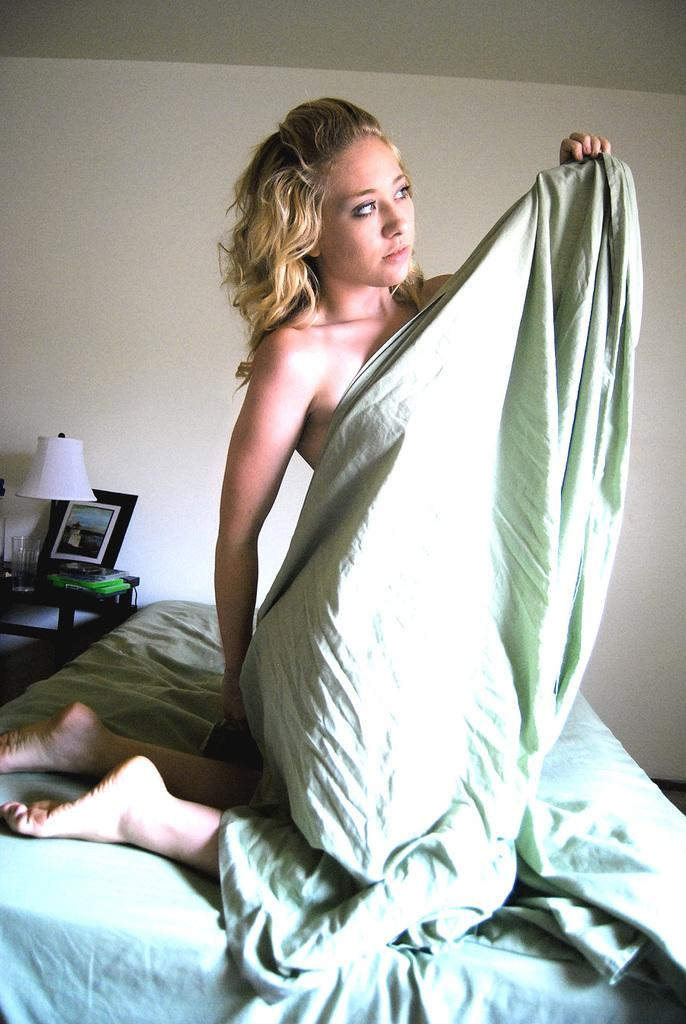Who is present in the image? There is a woman in the image. What object can be seen in the image? There is a cloth in the image. What can be seen in the background of the image? There is a bed, a photo frame, and a lamp in the background of the image. What type of ink can be seen on the woman's hands in the image? There is no ink visible on the woman's hands in the image. Are there any ants crawling on the cloth in the image? There are no ants present in the image. 